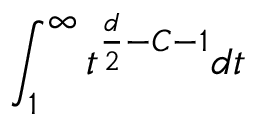Convert formula to latex. <formula><loc_0><loc_0><loc_500><loc_500>\int _ { 1 } ^ { \infty } t ^ { \frac { d } { 2 } - C - 1 } d t</formula> 